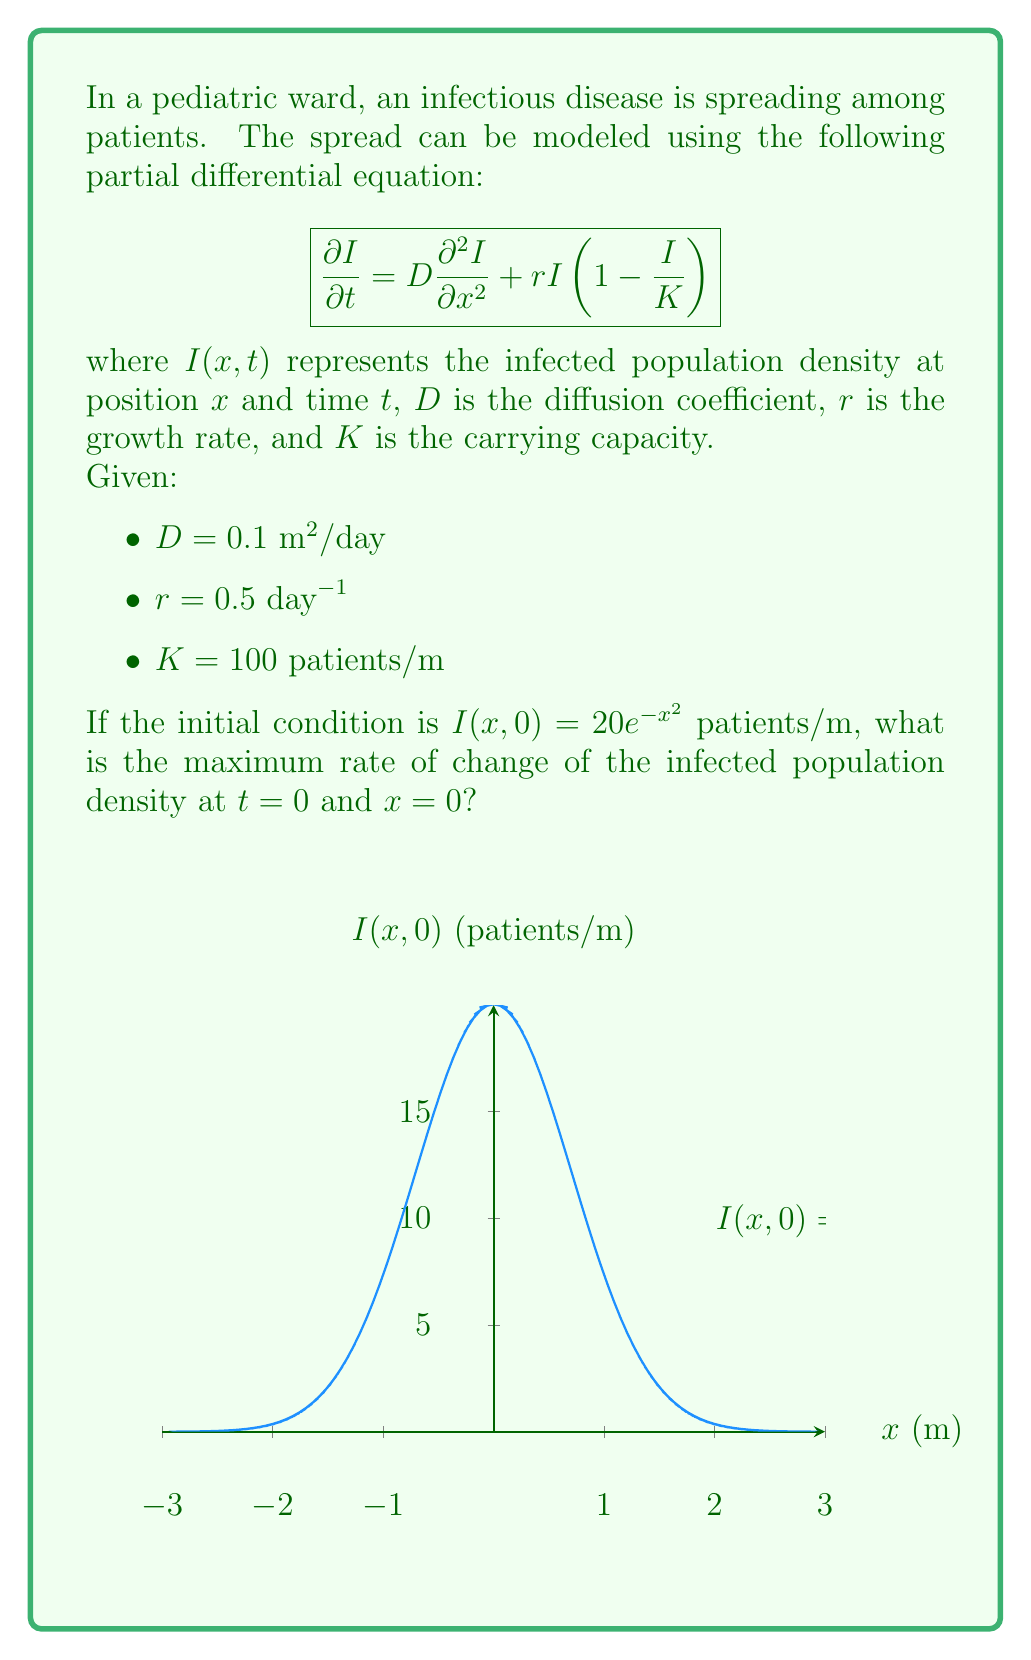Give your solution to this math problem. To find the maximum rate of change of the infected population density, we need to evaluate $\frac{\partial I}{\partial t}$ at $t=0$ and $x=0$.

Step 1: Evaluate the diffusion term at $t=0$ and $x=0$:
$$\frac{\partial^2 I}{\partial x^2} = \frac{\partial^2}{\partial x^2}(20e^{-x^2}) = 20(-2e^{-x^2} + 4x^2e^{-x^2})$$
At $x=0$: $\frac{\partial^2 I}{\partial x^2} = 20(-2) = -40$

Step 2: Evaluate the reaction term at $t=0$ and $x=0$:
$$rI(1-\frac{I}{K}) = 0.5 \cdot 20 \cdot (1-\frac{20}{100}) = 8$$

Step 3: Combine the terms in the PDE:
$$\frac{\partial I}{\partial t} = D\frac{\partial^2 I}{\partial x^2} + rI(1-\frac{I}{K})$$
$$\frac{\partial I}{\partial t} = 0.1 \cdot (-40) + 8 = -4 + 8 = 4$$

Therefore, the maximum rate of change of the infected population density at $t=0$ and $x=0$ is 4 patients/(m·day).
Answer: 4 patients/(m·day) 